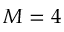<formula> <loc_0><loc_0><loc_500><loc_500>M = 4</formula> 